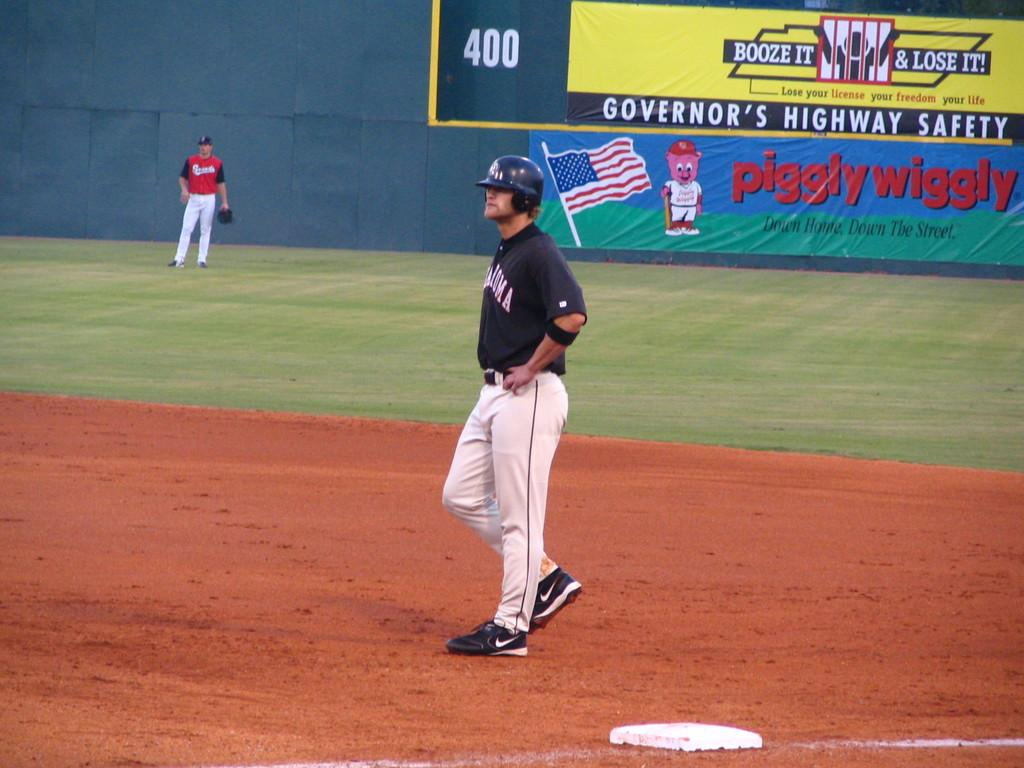<image>
Offer a succinct explanation of the picture presented. A piggly wiggly sign is hanging off the outfield wall at a baseball game. 